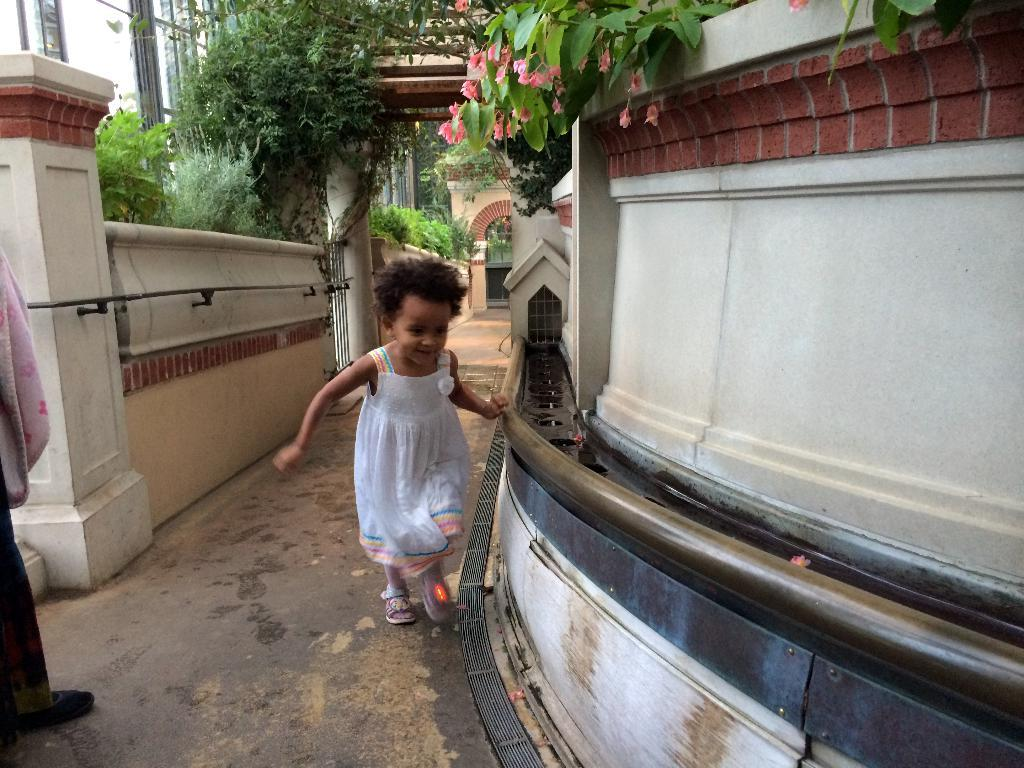Who is the main subject in the picture? There is a girl in the picture. What is the girl wearing? The girl is wearing a white frock. What is the girl doing in the picture? The girl is running. What can be seen in the background of the picture? There are trees visible in the picture. What type of credit does the girl receive for her actions in the picture? There is no mention of credit or any evaluation of the girl's actions in the picture. 